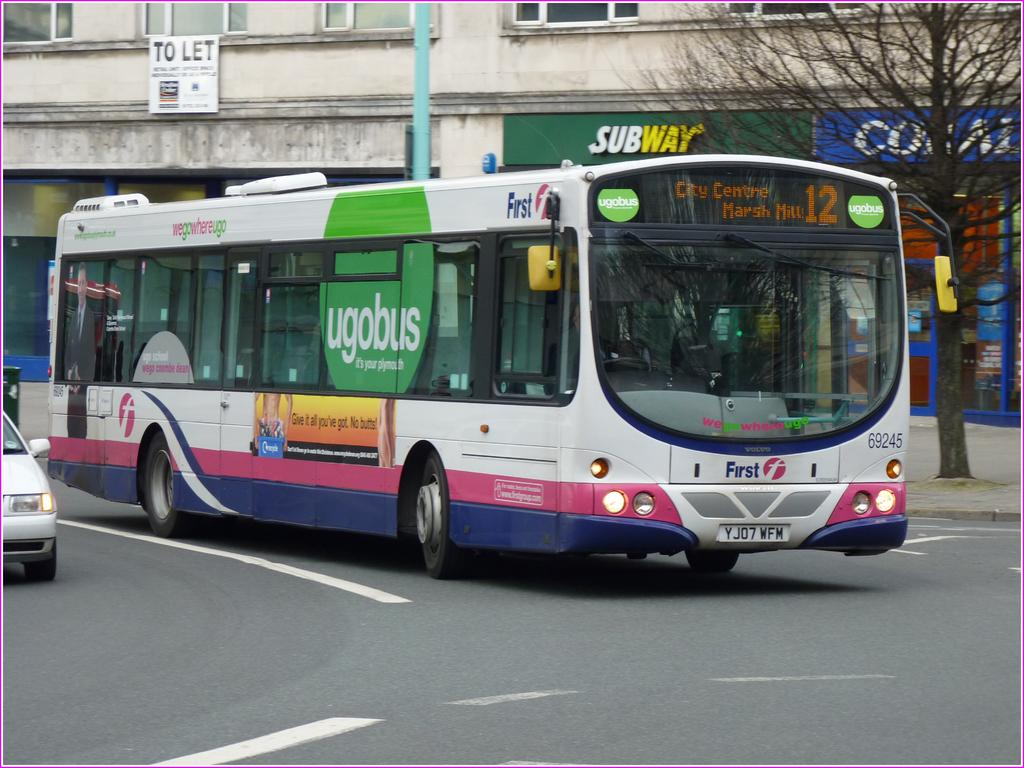<image>
Summarize the visual content of the image. A bus driving down the street is heading towards City Centre. 